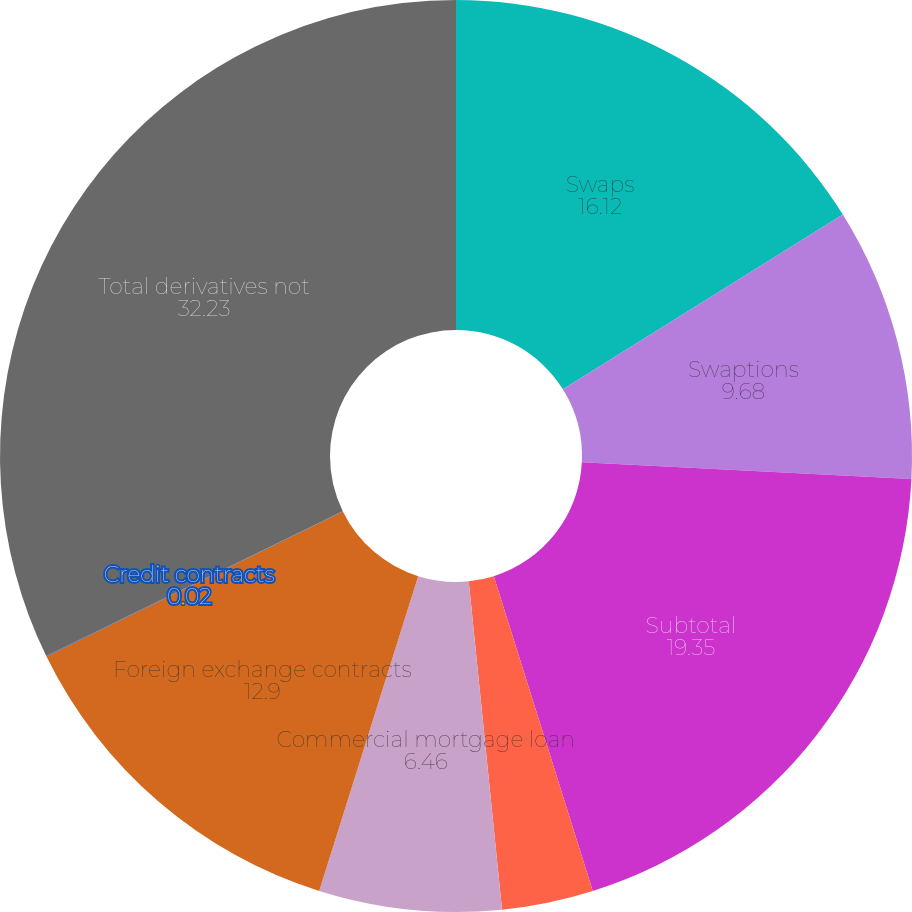Convert chart to OTSL. <chart><loc_0><loc_0><loc_500><loc_500><pie_chart><fcel>Swaps<fcel>Swaptions<fcel>Subtotal<fcel>Mortgage-backed securities<fcel>Commercial mortgage loan<fcel>Foreign exchange contracts<fcel>Credit contracts<fcel>Total derivatives not<nl><fcel>16.12%<fcel>9.68%<fcel>19.35%<fcel>3.24%<fcel>6.46%<fcel>12.9%<fcel>0.02%<fcel>32.23%<nl></chart> 